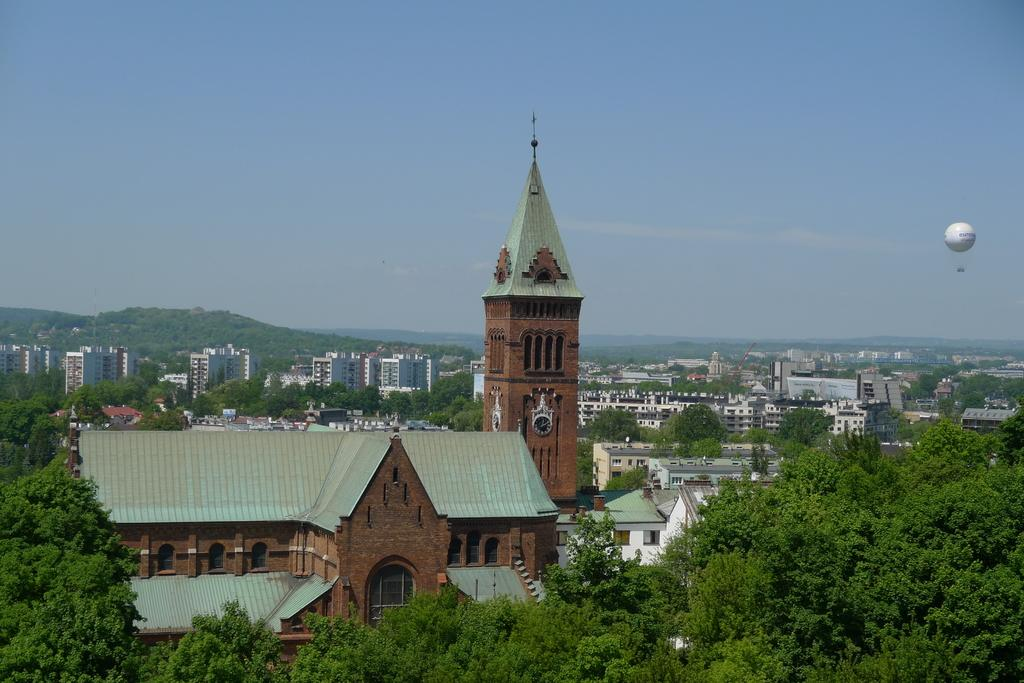What type of natural elements can be seen in the image? There are trees in the image. What type of man-made structures are present in the image? There are buildings in the image. What type of geographical feature can be seen in the image? There are mountains in the image. What is floating in the air in the image? There is a parachute in the air in the image. What is visible in the background of the image? The sky is visible in the background of the image. Can you tell me how many coaches are driving through the mountains in the image? There are no coaches present in the image; it features trees, buildings, mountains, a parachute, and the sky. What type of bee can be seen flying near the parachute in the image? There are no bees present in the image; it only features a parachute in the air. 